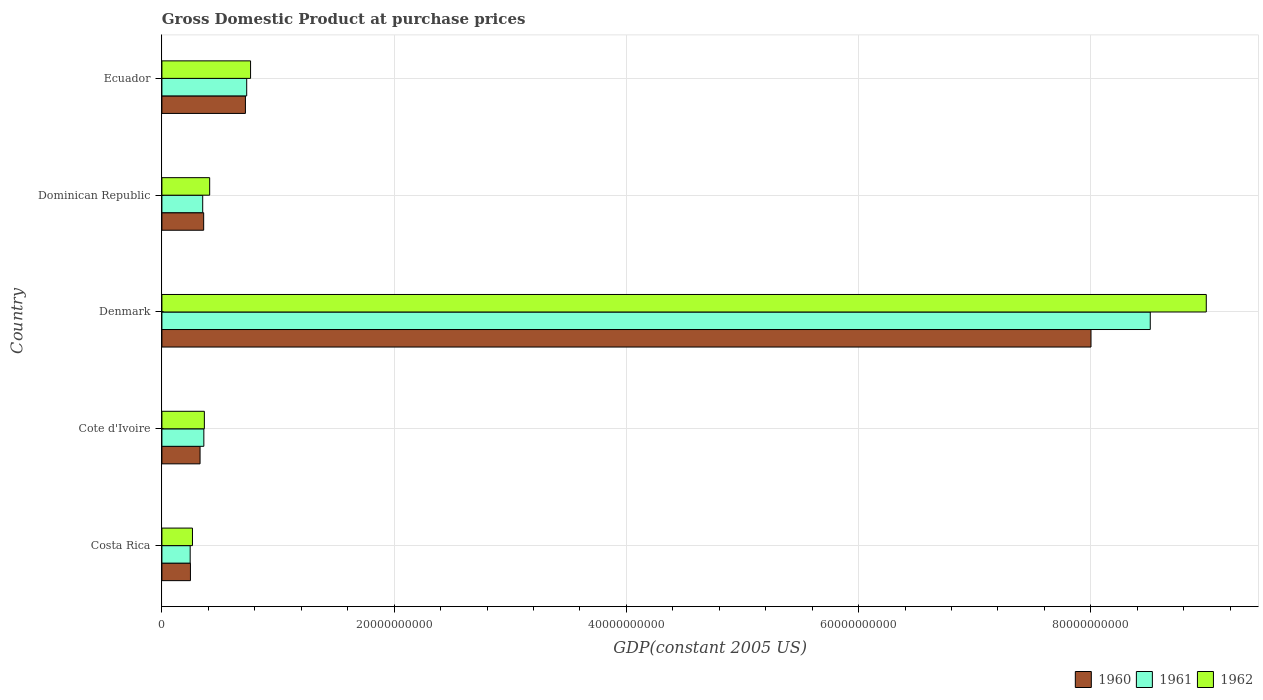How many groups of bars are there?
Your answer should be very brief. 5. How many bars are there on the 5th tick from the bottom?
Offer a very short reply. 3. What is the GDP at purchase prices in 1962 in Costa Rica?
Provide a succinct answer. 2.63e+09. Across all countries, what is the maximum GDP at purchase prices in 1960?
Give a very brief answer. 8.00e+1. Across all countries, what is the minimum GDP at purchase prices in 1961?
Make the answer very short. 2.43e+09. In which country was the GDP at purchase prices in 1962 maximum?
Provide a succinct answer. Denmark. In which country was the GDP at purchase prices in 1961 minimum?
Give a very brief answer. Costa Rica. What is the total GDP at purchase prices in 1961 in the graph?
Ensure brevity in your answer.  1.02e+11. What is the difference between the GDP at purchase prices in 1961 in Denmark and that in Dominican Republic?
Keep it short and to the point. 8.16e+1. What is the difference between the GDP at purchase prices in 1960 in Denmark and the GDP at purchase prices in 1962 in Cote d'Ivoire?
Provide a succinct answer. 7.64e+1. What is the average GDP at purchase prices in 1962 per country?
Make the answer very short. 2.16e+1. What is the difference between the GDP at purchase prices in 1961 and GDP at purchase prices in 1960 in Denmark?
Offer a terse response. 5.10e+09. What is the ratio of the GDP at purchase prices in 1961 in Costa Rica to that in Ecuador?
Ensure brevity in your answer.  0.33. Is the difference between the GDP at purchase prices in 1961 in Cote d'Ivoire and Dominican Republic greater than the difference between the GDP at purchase prices in 1960 in Cote d'Ivoire and Dominican Republic?
Make the answer very short. Yes. What is the difference between the highest and the second highest GDP at purchase prices in 1960?
Your response must be concise. 7.28e+1. What is the difference between the highest and the lowest GDP at purchase prices in 1960?
Ensure brevity in your answer.  7.76e+1. Is the sum of the GDP at purchase prices in 1960 in Cote d'Ivoire and Denmark greater than the maximum GDP at purchase prices in 1961 across all countries?
Offer a very short reply. No. Is it the case that in every country, the sum of the GDP at purchase prices in 1960 and GDP at purchase prices in 1961 is greater than the GDP at purchase prices in 1962?
Offer a very short reply. Yes. How many bars are there?
Your answer should be compact. 15. What is the difference between two consecutive major ticks on the X-axis?
Keep it short and to the point. 2.00e+1. Does the graph contain any zero values?
Give a very brief answer. No. Does the graph contain grids?
Give a very brief answer. Yes. How many legend labels are there?
Provide a succinct answer. 3. What is the title of the graph?
Offer a terse response. Gross Domestic Product at purchase prices. What is the label or title of the X-axis?
Make the answer very short. GDP(constant 2005 US). What is the GDP(constant 2005 US) of 1960 in Costa Rica?
Offer a terse response. 2.46e+09. What is the GDP(constant 2005 US) of 1961 in Costa Rica?
Make the answer very short. 2.43e+09. What is the GDP(constant 2005 US) of 1962 in Costa Rica?
Provide a short and direct response. 2.63e+09. What is the GDP(constant 2005 US) of 1960 in Cote d'Ivoire?
Provide a succinct answer. 3.29e+09. What is the GDP(constant 2005 US) in 1961 in Cote d'Ivoire?
Offer a terse response. 3.61e+09. What is the GDP(constant 2005 US) of 1962 in Cote d'Ivoire?
Make the answer very short. 3.66e+09. What is the GDP(constant 2005 US) in 1960 in Denmark?
Offer a very short reply. 8.00e+1. What is the GDP(constant 2005 US) of 1961 in Denmark?
Your answer should be compact. 8.51e+1. What is the GDP(constant 2005 US) in 1962 in Denmark?
Offer a terse response. 8.99e+1. What is the GDP(constant 2005 US) of 1960 in Dominican Republic?
Ensure brevity in your answer.  3.60e+09. What is the GDP(constant 2005 US) of 1961 in Dominican Republic?
Make the answer very short. 3.51e+09. What is the GDP(constant 2005 US) in 1962 in Dominican Republic?
Ensure brevity in your answer.  4.11e+09. What is the GDP(constant 2005 US) of 1960 in Ecuador?
Offer a terse response. 7.19e+09. What is the GDP(constant 2005 US) of 1961 in Ecuador?
Provide a succinct answer. 7.30e+09. What is the GDP(constant 2005 US) of 1962 in Ecuador?
Make the answer very short. 7.64e+09. Across all countries, what is the maximum GDP(constant 2005 US) in 1960?
Offer a terse response. 8.00e+1. Across all countries, what is the maximum GDP(constant 2005 US) in 1961?
Offer a terse response. 8.51e+1. Across all countries, what is the maximum GDP(constant 2005 US) of 1962?
Your answer should be very brief. 8.99e+1. Across all countries, what is the minimum GDP(constant 2005 US) of 1960?
Your answer should be compact. 2.46e+09. Across all countries, what is the minimum GDP(constant 2005 US) in 1961?
Make the answer very short. 2.43e+09. Across all countries, what is the minimum GDP(constant 2005 US) of 1962?
Your answer should be very brief. 2.63e+09. What is the total GDP(constant 2005 US) in 1960 in the graph?
Keep it short and to the point. 9.66e+1. What is the total GDP(constant 2005 US) in 1961 in the graph?
Your answer should be compact. 1.02e+11. What is the total GDP(constant 2005 US) in 1962 in the graph?
Provide a succinct answer. 1.08e+11. What is the difference between the GDP(constant 2005 US) of 1960 in Costa Rica and that in Cote d'Ivoire?
Make the answer very short. -8.28e+08. What is the difference between the GDP(constant 2005 US) of 1961 in Costa Rica and that in Cote d'Ivoire?
Your answer should be compact. -1.18e+09. What is the difference between the GDP(constant 2005 US) in 1962 in Costa Rica and that in Cote d'Ivoire?
Your answer should be compact. -1.02e+09. What is the difference between the GDP(constant 2005 US) in 1960 in Costa Rica and that in Denmark?
Provide a succinct answer. -7.76e+1. What is the difference between the GDP(constant 2005 US) of 1961 in Costa Rica and that in Denmark?
Ensure brevity in your answer.  -8.27e+1. What is the difference between the GDP(constant 2005 US) of 1962 in Costa Rica and that in Denmark?
Provide a short and direct response. -8.73e+1. What is the difference between the GDP(constant 2005 US) of 1960 in Costa Rica and that in Dominican Republic?
Keep it short and to the point. -1.14e+09. What is the difference between the GDP(constant 2005 US) of 1961 in Costa Rica and that in Dominican Republic?
Provide a short and direct response. -1.08e+09. What is the difference between the GDP(constant 2005 US) of 1962 in Costa Rica and that in Dominican Republic?
Make the answer very short. -1.48e+09. What is the difference between the GDP(constant 2005 US) in 1960 in Costa Rica and that in Ecuador?
Provide a succinct answer. -4.73e+09. What is the difference between the GDP(constant 2005 US) of 1961 in Costa Rica and that in Ecuador?
Give a very brief answer. -4.87e+09. What is the difference between the GDP(constant 2005 US) of 1962 in Costa Rica and that in Ecuador?
Your answer should be compact. -5.00e+09. What is the difference between the GDP(constant 2005 US) in 1960 in Cote d'Ivoire and that in Denmark?
Offer a terse response. -7.67e+1. What is the difference between the GDP(constant 2005 US) in 1961 in Cote d'Ivoire and that in Denmark?
Give a very brief answer. -8.15e+1. What is the difference between the GDP(constant 2005 US) in 1962 in Cote d'Ivoire and that in Denmark?
Offer a terse response. -8.63e+1. What is the difference between the GDP(constant 2005 US) of 1960 in Cote d'Ivoire and that in Dominican Republic?
Your answer should be very brief. -3.12e+08. What is the difference between the GDP(constant 2005 US) of 1961 in Cote d'Ivoire and that in Dominican Republic?
Give a very brief answer. 9.81e+07. What is the difference between the GDP(constant 2005 US) in 1962 in Cote d'Ivoire and that in Dominican Republic?
Your response must be concise. -4.57e+08. What is the difference between the GDP(constant 2005 US) of 1960 in Cote d'Ivoire and that in Ecuador?
Your answer should be very brief. -3.91e+09. What is the difference between the GDP(constant 2005 US) in 1961 in Cote d'Ivoire and that in Ecuador?
Give a very brief answer. -3.69e+09. What is the difference between the GDP(constant 2005 US) in 1962 in Cote d'Ivoire and that in Ecuador?
Ensure brevity in your answer.  -3.98e+09. What is the difference between the GDP(constant 2005 US) of 1960 in Denmark and that in Dominican Republic?
Your answer should be very brief. 7.64e+1. What is the difference between the GDP(constant 2005 US) of 1961 in Denmark and that in Dominican Republic?
Offer a terse response. 8.16e+1. What is the difference between the GDP(constant 2005 US) in 1962 in Denmark and that in Dominican Republic?
Your answer should be compact. 8.58e+1. What is the difference between the GDP(constant 2005 US) in 1960 in Denmark and that in Ecuador?
Provide a succinct answer. 7.28e+1. What is the difference between the GDP(constant 2005 US) in 1961 in Denmark and that in Ecuador?
Give a very brief answer. 7.78e+1. What is the difference between the GDP(constant 2005 US) of 1962 in Denmark and that in Ecuador?
Your answer should be compact. 8.23e+1. What is the difference between the GDP(constant 2005 US) in 1960 in Dominican Republic and that in Ecuador?
Make the answer very short. -3.59e+09. What is the difference between the GDP(constant 2005 US) in 1961 in Dominican Republic and that in Ecuador?
Ensure brevity in your answer.  -3.79e+09. What is the difference between the GDP(constant 2005 US) of 1962 in Dominican Republic and that in Ecuador?
Your response must be concise. -3.52e+09. What is the difference between the GDP(constant 2005 US) in 1960 in Costa Rica and the GDP(constant 2005 US) in 1961 in Cote d'Ivoire?
Provide a succinct answer. -1.15e+09. What is the difference between the GDP(constant 2005 US) in 1960 in Costa Rica and the GDP(constant 2005 US) in 1962 in Cote d'Ivoire?
Offer a very short reply. -1.20e+09. What is the difference between the GDP(constant 2005 US) in 1961 in Costa Rica and the GDP(constant 2005 US) in 1962 in Cote d'Ivoire?
Offer a very short reply. -1.22e+09. What is the difference between the GDP(constant 2005 US) of 1960 in Costa Rica and the GDP(constant 2005 US) of 1961 in Denmark?
Make the answer very short. -8.27e+1. What is the difference between the GDP(constant 2005 US) in 1960 in Costa Rica and the GDP(constant 2005 US) in 1962 in Denmark?
Make the answer very short. -8.75e+1. What is the difference between the GDP(constant 2005 US) of 1961 in Costa Rica and the GDP(constant 2005 US) of 1962 in Denmark?
Offer a very short reply. -8.75e+1. What is the difference between the GDP(constant 2005 US) in 1960 in Costa Rica and the GDP(constant 2005 US) in 1961 in Dominican Republic?
Provide a short and direct response. -1.06e+09. What is the difference between the GDP(constant 2005 US) in 1960 in Costa Rica and the GDP(constant 2005 US) in 1962 in Dominican Republic?
Provide a short and direct response. -1.66e+09. What is the difference between the GDP(constant 2005 US) of 1961 in Costa Rica and the GDP(constant 2005 US) of 1962 in Dominican Republic?
Provide a succinct answer. -1.68e+09. What is the difference between the GDP(constant 2005 US) of 1960 in Costa Rica and the GDP(constant 2005 US) of 1961 in Ecuador?
Your response must be concise. -4.85e+09. What is the difference between the GDP(constant 2005 US) of 1960 in Costa Rica and the GDP(constant 2005 US) of 1962 in Ecuador?
Your answer should be compact. -5.18e+09. What is the difference between the GDP(constant 2005 US) of 1961 in Costa Rica and the GDP(constant 2005 US) of 1962 in Ecuador?
Make the answer very short. -5.20e+09. What is the difference between the GDP(constant 2005 US) in 1960 in Cote d'Ivoire and the GDP(constant 2005 US) in 1961 in Denmark?
Provide a short and direct response. -8.18e+1. What is the difference between the GDP(constant 2005 US) in 1960 in Cote d'Ivoire and the GDP(constant 2005 US) in 1962 in Denmark?
Offer a terse response. -8.67e+1. What is the difference between the GDP(constant 2005 US) of 1961 in Cote d'Ivoire and the GDP(constant 2005 US) of 1962 in Denmark?
Your answer should be compact. -8.63e+1. What is the difference between the GDP(constant 2005 US) in 1960 in Cote d'Ivoire and the GDP(constant 2005 US) in 1961 in Dominican Republic?
Provide a short and direct response. -2.28e+08. What is the difference between the GDP(constant 2005 US) of 1960 in Cote d'Ivoire and the GDP(constant 2005 US) of 1962 in Dominican Republic?
Ensure brevity in your answer.  -8.27e+08. What is the difference between the GDP(constant 2005 US) in 1961 in Cote d'Ivoire and the GDP(constant 2005 US) in 1962 in Dominican Republic?
Make the answer very short. -5.01e+08. What is the difference between the GDP(constant 2005 US) in 1960 in Cote d'Ivoire and the GDP(constant 2005 US) in 1961 in Ecuador?
Offer a very short reply. -4.02e+09. What is the difference between the GDP(constant 2005 US) in 1960 in Cote d'Ivoire and the GDP(constant 2005 US) in 1962 in Ecuador?
Make the answer very short. -4.35e+09. What is the difference between the GDP(constant 2005 US) of 1961 in Cote d'Ivoire and the GDP(constant 2005 US) of 1962 in Ecuador?
Make the answer very short. -4.02e+09. What is the difference between the GDP(constant 2005 US) of 1960 in Denmark and the GDP(constant 2005 US) of 1961 in Dominican Republic?
Make the answer very short. 7.65e+1. What is the difference between the GDP(constant 2005 US) of 1960 in Denmark and the GDP(constant 2005 US) of 1962 in Dominican Republic?
Give a very brief answer. 7.59e+1. What is the difference between the GDP(constant 2005 US) of 1961 in Denmark and the GDP(constant 2005 US) of 1962 in Dominican Republic?
Provide a short and direct response. 8.10e+1. What is the difference between the GDP(constant 2005 US) in 1960 in Denmark and the GDP(constant 2005 US) in 1961 in Ecuador?
Offer a very short reply. 7.27e+1. What is the difference between the GDP(constant 2005 US) of 1960 in Denmark and the GDP(constant 2005 US) of 1962 in Ecuador?
Offer a very short reply. 7.24e+1. What is the difference between the GDP(constant 2005 US) of 1961 in Denmark and the GDP(constant 2005 US) of 1962 in Ecuador?
Your answer should be very brief. 7.75e+1. What is the difference between the GDP(constant 2005 US) in 1960 in Dominican Republic and the GDP(constant 2005 US) in 1961 in Ecuador?
Offer a very short reply. -3.71e+09. What is the difference between the GDP(constant 2005 US) of 1960 in Dominican Republic and the GDP(constant 2005 US) of 1962 in Ecuador?
Provide a succinct answer. -4.04e+09. What is the difference between the GDP(constant 2005 US) in 1961 in Dominican Republic and the GDP(constant 2005 US) in 1962 in Ecuador?
Provide a succinct answer. -4.12e+09. What is the average GDP(constant 2005 US) of 1960 per country?
Offer a very short reply. 1.93e+1. What is the average GDP(constant 2005 US) of 1961 per country?
Offer a very short reply. 2.04e+1. What is the average GDP(constant 2005 US) in 1962 per country?
Provide a succinct answer. 2.16e+1. What is the difference between the GDP(constant 2005 US) in 1960 and GDP(constant 2005 US) in 1961 in Costa Rica?
Give a very brief answer. 2.35e+07. What is the difference between the GDP(constant 2005 US) in 1960 and GDP(constant 2005 US) in 1962 in Costa Rica?
Provide a short and direct response. -1.75e+08. What is the difference between the GDP(constant 2005 US) of 1961 and GDP(constant 2005 US) of 1962 in Costa Rica?
Keep it short and to the point. -1.98e+08. What is the difference between the GDP(constant 2005 US) in 1960 and GDP(constant 2005 US) in 1961 in Cote d'Ivoire?
Keep it short and to the point. -3.26e+08. What is the difference between the GDP(constant 2005 US) in 1960 and GDP(constant 2005 US) in 1962 in Cote d'Ivoire?
Provide a short and direct response. -3.71e+08. What is the difference between the GDP(constant 2005 US) of 1961 and GDP(constant 2005 US) of 1962 in Cote d'Ivoire?
Ensure brevity in your answer.  -4.43e+07. What is the difference between the GDP(constant 2005 US) of 1960 and GDP(constant 2005 US) of 1961 in Denmark?
Ensure brevity in your answer.  -5.10e+09. What is the difference between the GDP(constant 2005 US) of 1960 and GDP(constant 2005 US) of 1962 in Denmark?
Give a very brief answer. -9.93e+09. What is the difference between the GDP(constant 2005 US) of 1961 and GDP(constant 2005 US) of 1962 in Denmark?
Ensure brevity in your answer.  -4.82e+09. What is the difference between the GDP(constant 2005 US) in 1960 and GDP(constant 2005 US) in 1961 in Dominican Republic?
Give a very brief answer. 8.32e+07. What is the difference between the GDP(constant 2005 US) of 1960 and GDP(constant 2005 US) of 1962 in Dominican Republic?
Ensure brevity in your answer.  -5.16e+08. What is the difference between the GDP(constant 2005 US) of 1961 and GDP(constant 2005 US) of 1962 in Dominican Republic?
Your answer should be compact. -5.99e+08. What is the difference between the GDP(constant 2005 US) of 1960 and GDP(constant 2005 US) of 1961 in Ecuador?
Provide a short and direct response. -1.11e+08. What is the difference between the GDP(constant 2005 US) in 1960 and GDP(constant 2005 US) in 1962 in Ecuador?
Your response must be concise. -4.44e+08. What is the difference between the GDP(constant 2005 US) of 1961 and GDP(constant 2005 US) of 1962 in Ecuador?
Make the answer very short. -3.33e+08. What is the ratio of the GDP(constant 2005 US) in 1960 in Costa Rica to that in Cote d'Ivoire?
Provide a short and direct response. 0.75. What is the ratio of the GDP(constant 2005 US) of 1961 in Costa Rica to that in Cote d'Ivoire?
Keep it short and to the point. 0.67. What is the ratio of the GDP(constant 2005 US) of 1962 in Costa Rica to that in Cote d'Ivoire?
Your answer should be very brief. 0.72. What is the ratio of the GDP(constant 2005 US) in 1960 in Costa Rica to that in Denmark?
Your response must be concise. 0.03. What is the ratio of the GDP(constant 2005 US) of 1961 in Costa Rica to that in Denmark?
Ensure brevity in your answer.  0.03. What is the ratio of the GDP(constant 2005 US) of 1962 in Costa Rica to that in Denmark?
Offer a very short reply. 0.03. What is the ratio of the GDP(constant 2005 US) of 1960 in Costa Rica to that in Dominican Republic?
Give a very brief answer. 0.68. What is the ratio of the GDP(constant 2005 US) of 1961 in Costa Rica to that in Dominican Republic?
Offer a terse response. 0.69. What is the ratio of the GDP(constant 2005 US) of 1962 in Costa Rica to that in Dominican Republic?
Ensure brevity in your answer.  0.64. What is the ratio of the GDP(constant 2005 US) of 1960 in Costa Rica to that in Ecuador?
Offer a very short reply. 0.34. What is the ratio of the GDP(constant 2005 US) in 1961 in Costa Rica to that in Ecuador?
Your answer should be very brief. 0.33. What is the ratio of the GDP(constant 2005 US) of 1962 in Costa Rica to that in Ecuador?
Your answer should be compact. 0.34. What is the ratio of the GDP(constant 2005 US) in 1960 in Cote d'Ivoire to that in Denmark?
Your answer should be very brief. 0.04. What is the ratio of the GDP(constant 2005 US) of 1961 in Cote d'Ivoire to that in Denmark?
Provide a succinct answer. 0.04. What is the ratio of the GDP(constant 2005 US) in 1962 in Cote d'Ivoire to that in Denmark?
Provide a succinct answer. 0.04. What is the ratio of the GDP(constant 2005 US) in 1960 in Cote d'Ivoire to that in Dominican Republic?
Offer a terse response. 0.91. What is the ratio of the GDP(constant 2005 US) of 1961 in Cote d'Ivoire to that in Dominican Republic?
Your answer should be compact. 1.03. What is the ratio of the GDP(constant 2005 US) in 1962 in Cote d'Ivoire to that in Dominican Republic?
Your answer should be compact. 0.89. What is the ratio of the GDP(constant 2005 US) of 1960 in Cote d'Ivoire to that in Ecuador?
Ensure brevity in your answer.  0.46. What is the ratio of the GDP(constant 2005 US) of 1961 in Cote d'Ivoire to that in Ecuador?
Offer a terse response. 0.49. What is the ratio of the GDP(constant 2005 US) in 1962 in Cote d'Ivoire to that in Ecuador?
Your answer should be compact. 0.48. What is the ratio of the GDP(constant 2005 US) of 1960 in Denmark to that in Dominican Republic?
Keep it short and to the point. 22.24. What is the ratio of the GDP(constant 2005 US) of 1961 in Denmark to that in Dominican Republic?
Provide a succinct answer. 24.22. What is the ratio of the GDP(constant 2005 US) in 1962 in Denmark to that in Dominican Republic?
Your answer should be very brief. 21.86. What is the ratio of the GDP(constant 2005 US) of 1960 in Denmark to that in Ecuador?
Your answer should be very brief. 11.12. What is the ratio of the GDP(constant 2005 US) of 1961 in Denmark to that in Ecuador?
Offer a terse response. 11.65. What is the ratio of the GDP(constant 2005 US) of 1962 in Denmark to that in Ecuador?
Keep it short and to the point. 11.78. What is the ratio of the GDP(constant 2005 US) in 1960 in Dominican Republic to that in Ecuador?
Provide a succinct answer. 0.5. What is the ratio of the GDP(constant 2005 US) in 1961 in Dominican Republic to that in Ecuador?
Keep it short and to the point. 0.48. What is the ratio of the GDP(constant 2005 US) of 1962 in Dominican Republic to that in Ecuador?
Your response must be concise. 0.54. What is the difference between the highest and the second highest GDP(constant 2005 US) in 1960?
Offer a terse response. 7.28e+1. What is the difference between the highest and the second highest GDP(constant 2005 US) of 1961?
Your answer should be very brief. 7.78e+1. What is the difference between the highest and the second highest GDP(constant 2005 US) in 1962?
Provide a succinct answer. 8.23e+1. What is the difference between the highest and the lowest GDP(constant 2005 US) of 1960?
Your answer should be compact. 7.76e+1. What is the difference between the highest and the lowest GDP(constant 2005 US) in 1961?
Provide a succinct answer. 8.27e+1. What is the difference between the highest and the lowest GDP(constant 2005 US) in 1962?
Keep it short and to the point. 8.73e+1. 